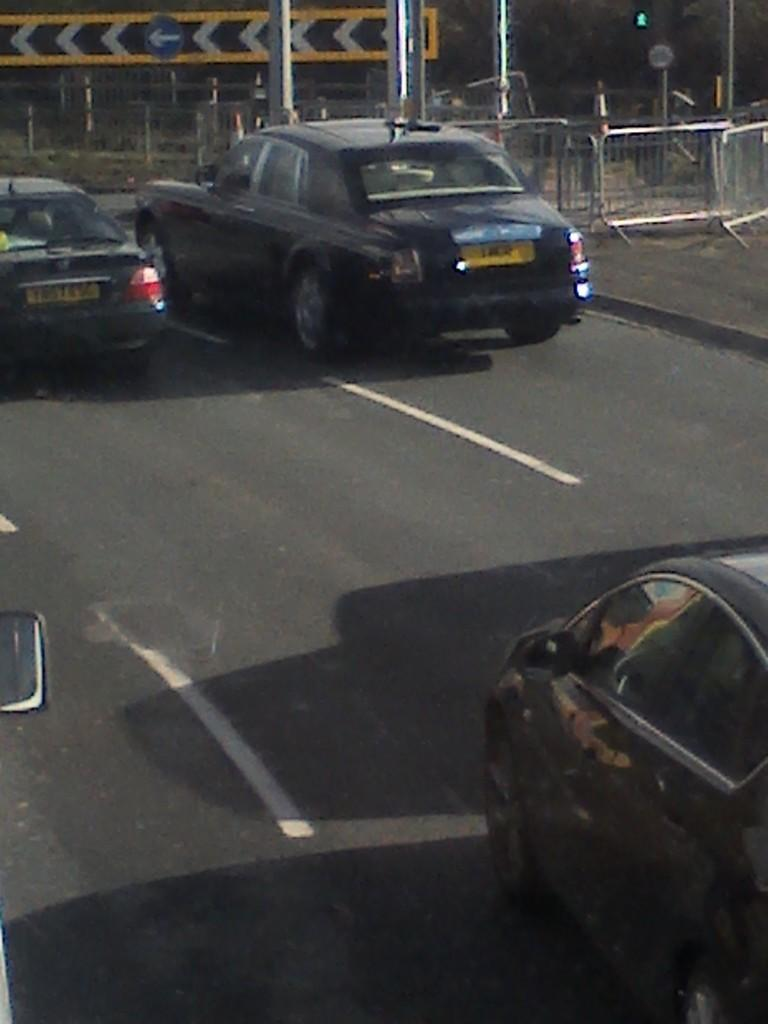What is the main subject of the image? The main subject of the image is a view of the road. What is happening on the road? Cars are moving on the road. What type of safety feature is visible in the image? There is a grill railing visible in the image. What can be used for navigation in the image? There is a yellow direction board in the image. How many girls are playing on the road in the image? There are no girls present in the image; it features a view of the road with moving cars and a yellow direction board. What is the sun doing in the image? There is no sun visible in the image; it is a view of the road with cars, a grill railing, and a yellow direction board. 